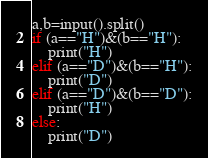Convert code to text. <code><loc_0><loc_0><loc_500><loc_500><_Python_>a,b=input().split()
if (a=="H")&(b=="H"):
    print("H")
elif (a=="D")&(b=="H"):
    print("D")
elif (a=="D")&(b=="D"):
    print("H")
else:
    print("D")</code> 